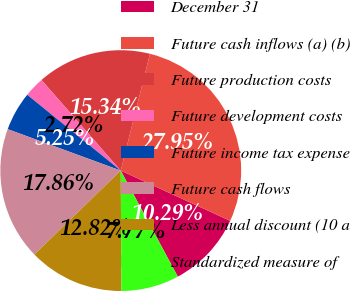Convert chart to OTSL. <chart><loc_0><loc_0><loc_500><loc_500><pie_chart><fcel>December 31<fcel>Future cash inflows (a) (b)<fcel>Future production costs<fcel>Future development costs<fcel>Future income tax expense<fcel>Future cash flows<fcel>Less annual discount (10 a<fcel>Standardized measure of<nl><fcel>10.29%<fcel>27.95%<fcel>15.34%<fcel>2.72%<fcel>5.25%<fcel>17.86%<fcel>12.82%<fcel>7.77%<nl></chart> 